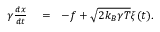Convert formula to latex. <formula><loc_0><loc_0><loc_500><loc_500>\begin{array} { r l r } { \gamma { \frac { d x } { d t } } } & = } & { - f + \sqrt { 2 k _ { B } \gamma T } \xi ( t ) . } \end{array}</formula> 